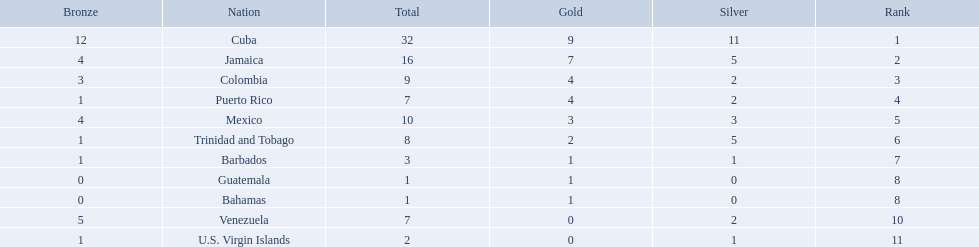Would you be able to parse every entry in this table? {'header': ['Bronze', 'Nation', 'Total', 'Gold', 'Silver', 'Rank'], 'rows': [['12', 'Cuba', '32', '9', '11', '1'], ['4', 'Jamaica', '16', '7', '5', '2'], ['3', 'Colombia', '9', '4', '2', '3'], ['1', 'Puerto Rico', '7', '4', '2', '4'], ['4', 'Mexico', '10', '3', '3', '5'], ['1', 'Trinidad and Tobago', '8', '2', '5', '6'], ['1', 'Barbados', '3', '1', '1', '7'], ['0', 'Guatemala', '1', '1', '0', '8'], ['0', 'Bahamas', '1', '1', '0', '8'], ['5', 'Venezuela', '7', '0', '2', '10'], ['1', 'U.S. Virgin Islands', '2', '0', '1', '11']]} Which teams have at exactly 4 gold medals? Colombia, Puerto Rico. Of those teams which has exactly 1 bronze medal? Puerto Rico. 